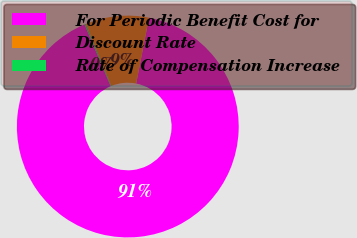<chart> <loc_0><loc_0><loc_500><loc_500><pie_chart><fcel>For Periodic Benefit Cost for<fcel>Discount Rate<fcel>Rate of Compensation Increase<nl><fcel>90.56%<fcel>9.24%<fcel>0.2%<nl></chart> 